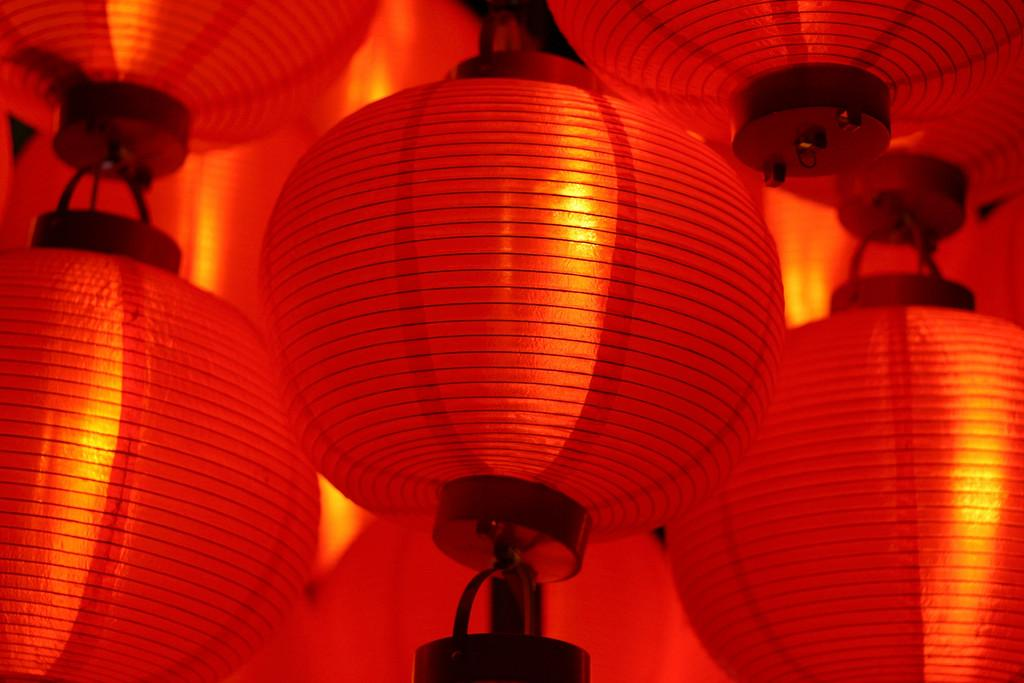What type of decorations are present in the image? There are paper lanterns in the image. What color are the paper lanterns? The paper lanterns are red in color. What type of writing instrument is being used by the writer in the image? There is no writer or writing instrument present in the image; it only features red paper lanterns. 